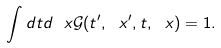Convert formula to latex. <formula><loc_0><loc_0><loc_500><loc_500>\int d t d \ x \mathcal { G } ( t ^ { \prime } , \ x ^ { \prime } , t , \ x ) = 1 .</formula> 